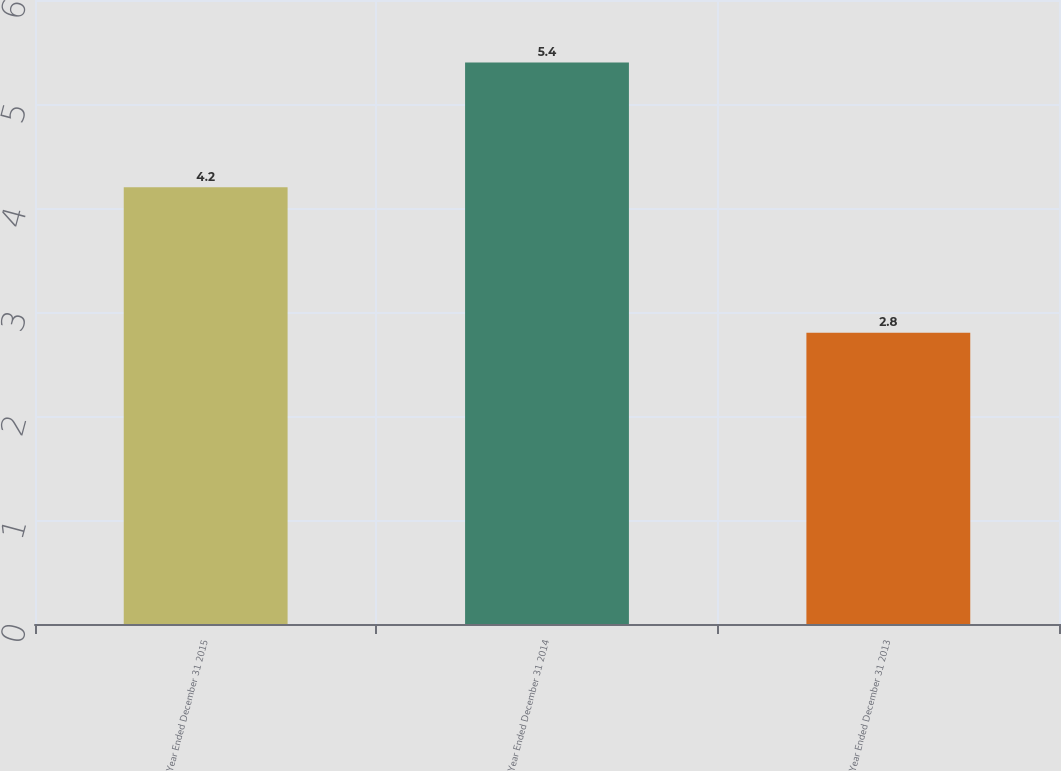Convert chart. <chart><loc_0><loc_0><loc_500><loc_500><bar_chart><fcel>Year Ended December 31 2015<fcel>Year Ended December 31 2014<fcel>Year Ended December 31 2013<nl><fcel>4.2<fcel>5.4<fcel>2.8<nl></chart> 